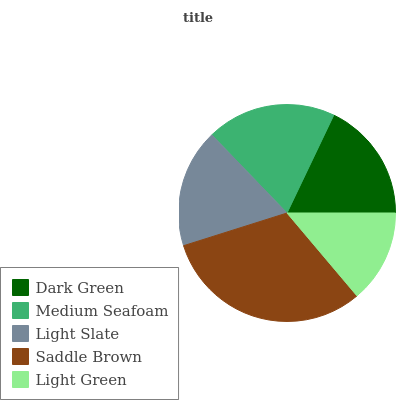Is Light Green the minimum?
Answer yes or no. Yes. Is Saddle Brown the maximum?
Answer yes or no. Yes. Is Medium Seafoam the minimum?
Answer yes or no. No. Is Medium Seafoam the maximum?
Answer yes or no. No. Is Medium Seafoam greater than Dark Green?
Answer yes or no. Yes. Is Dark Green less than Medium Seafoam?
Answer yes or no. Yes. Is Dark Green greater than Medium Seafoam?
Answer yes or no. No. Is Medium Seafoam less than Dark Green?
Answer yes or no. No. Is Dark Green the high median?
Answer yes or no. Yes. Is Dark Green the low median?
Answer yes or no. Yes. Is Light Slate the high median?
Answer yes or no. No. Is Light Green the low median?
Answer yes or no. No. 